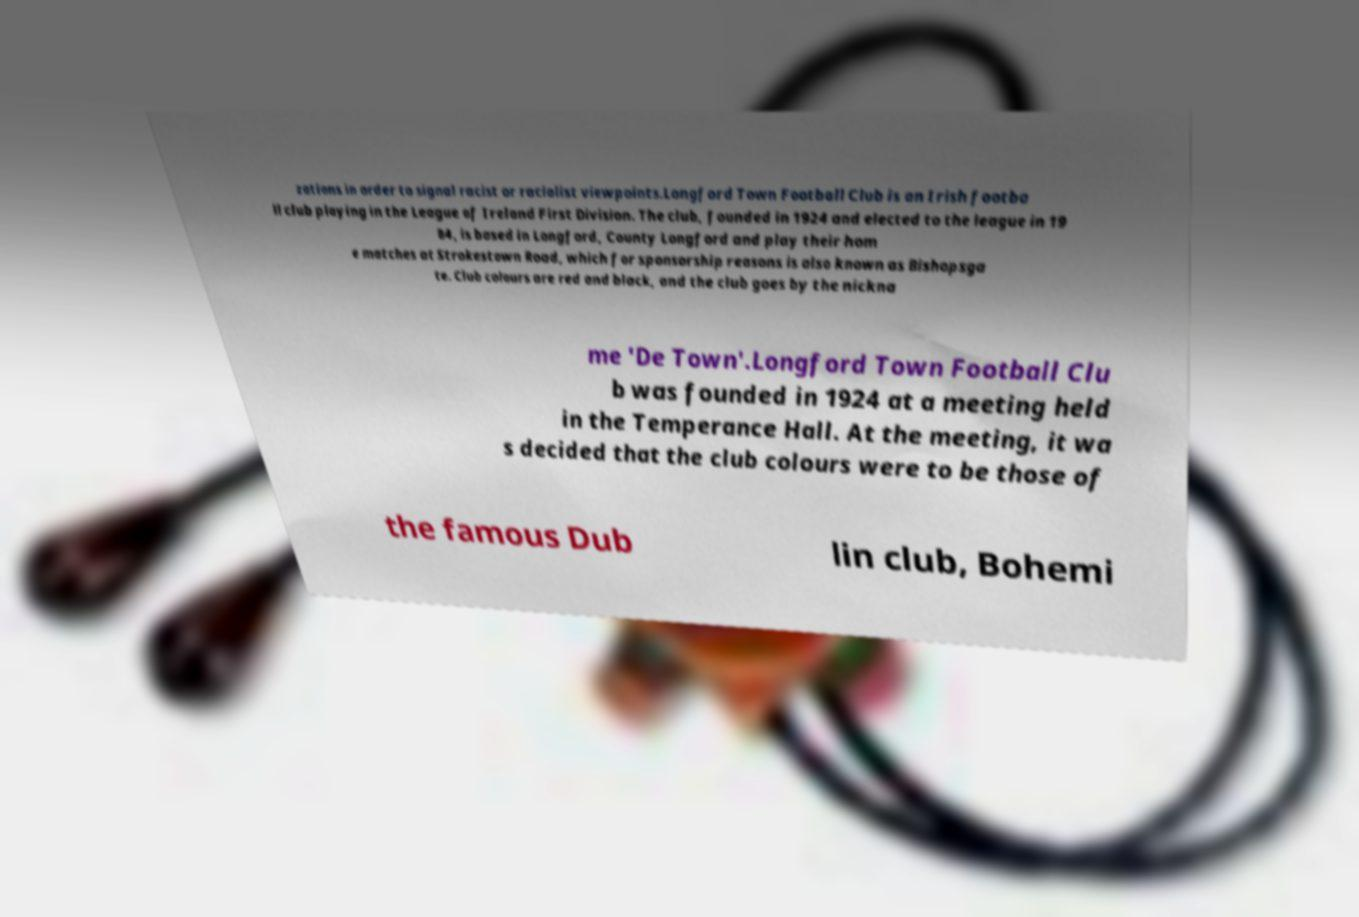Can you read and provide the text displayed in the image?This photo seems to have some interesting text. Can you extract and type it out for me? zations in order to signal racist or racialist viewpoints.Longford Town Football Club is an Irish footba ll club playing in the League of Ireland First Division. The club, founded in 1924 and elected to the league in 19 84, is based in Longford, County Longford and play their hom e matches at Strokestown Road, which for sponsorship reasons is also known as Bishopsga te. Club colours are red and black, and the club goes by the nickna me 'De Town'.Longford Town Football Clu b was founded in 1924 at a meeting held in the Temperance Hall. At the meeting, it wa s decided that the club colours were to be those of the famous Dub lin club, Bohemi 